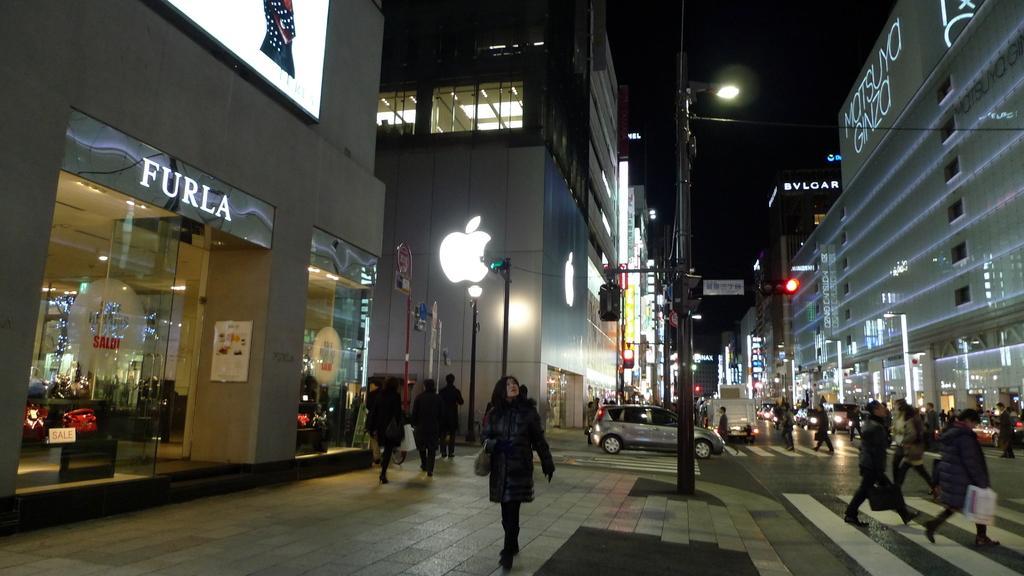Can you describe this image briefly? In this image we can see a group of people standing on the ground, some persons are holding bags in their hands, the group of vehicles parked on the road. In the center of the image we can see group of traffic lights, poles and sign boards. In the background, we can see buildings with windows, lights, screen and the sky. 